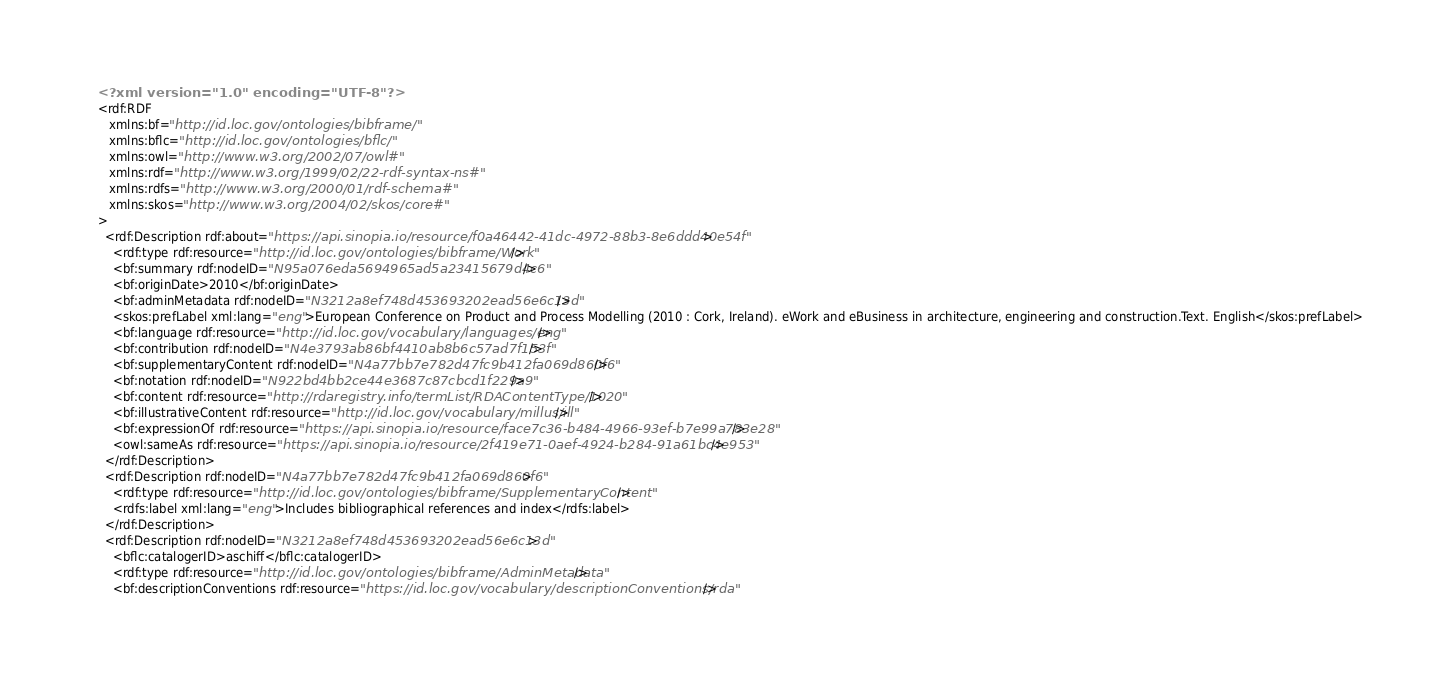Convert code to text. <code><loc_0><loc_0><loc_500><loc_500><_XML_><?xml version="1.0" encoding="UTF-8"?>
<rdf:RDF
   xmlns:bf="http://id.loc.gov/ontologies/bibframe/"
   xmlns:bflc="http://id.loc.gov/ontologies/bflc/"
   xmlns:owl="http://www.w3.org/2002/07/owl#"
   xmlns:rdf="http://www.w3.org/1999/02/22-rdf-syntax-ns#"
   xmlns:rdfs="http://www.w3.org/2000/01/rdf-schema#"
   xmlns:skos="http://www.w3.org/2004/02/skos/core#"
>
  <rdf:Description rdf:about="https://api.sinopia.io/resource/f0a46442-41dc-4972-88b3-8e6ddd40e54f">
    <rdf:type rdf:resource="http://id.loc.gov/ontologies/bibframe/Work"/>
    <bf:summary rdf:nodeID="N95a076eda5694965ad5a23415679d4c6"/>
    <bf:originDate>2010</bf:originDate>
    <bf:adminMetadata rdf:nodeID="N3212a8ef748d453693202ead56e6c13d"/>
    <skos:prefLabel xml:lang="eng">European Conference on Product and Process Modelling (2010 : Cork, Ireland). eWork and eBusiness in architecture, engineering and construction.Text. English</skos:prefLabel>
    <bf:language rdf:resource="http://id.loc.gov/vocabulary/languages/eng"/>
    <bf:contribution rdf:nodeID="N4e3793ab86bf4410ab8b6c57ad7f153f"/>
    <bf:supplementaryContent rdf:nodeID="N4a77bb7e782d47fc9b412fa069d860f6"/>
    <bf:notation rdf:nodeID="N922bd4bb2ce44e3687c87cbcd1f229a9"/>
    <bf:content rdf:resource="http://rdaregistry.info/termList/RDAContentType/1020"/>
    <bf:illustrativeContent rdf:resource="http://id.loc.gov/vocabulary/millus/ill"/>
    <bf:expressionOf rdf:resource="https://api.sinopia.io/resource/face7c36-b484-4966-93ef-b7e99a783e28"/>
    <owl:sameAs rdf:resource="https://api.sinopia.io/resource/2f419e71-0aef-4924-b284-91a61bc4e953"/>
  </rdf:Description>
  <rdf:Description rdf:nodeID="N4a77bb7e782d47fc9b412fa069d860f6">
    <rdf:type rdf:resource="http://id.loc.gov/ontologies/bibframe/SupplementaryContent"/>
    <rdfs:label xml:lang="eng">Includes bibliographical references and index</rdfs:label>
  </rdf:Description>
  <rdf:Description rdf:nodeID="N3212a8ef748d453693202ead56e6c13d">
    <bflc:catalogerID>aschiff</bflc:catalogerID>
    <rdf:type rdf:resource="http://id.loc.gov/ontologies/bibframe/AdminMetadata"/>
    <bf:descriptionConventions rdf:resource="https://id.loc.gov/vocabulary/descriptionConventions/rda"/></code> 